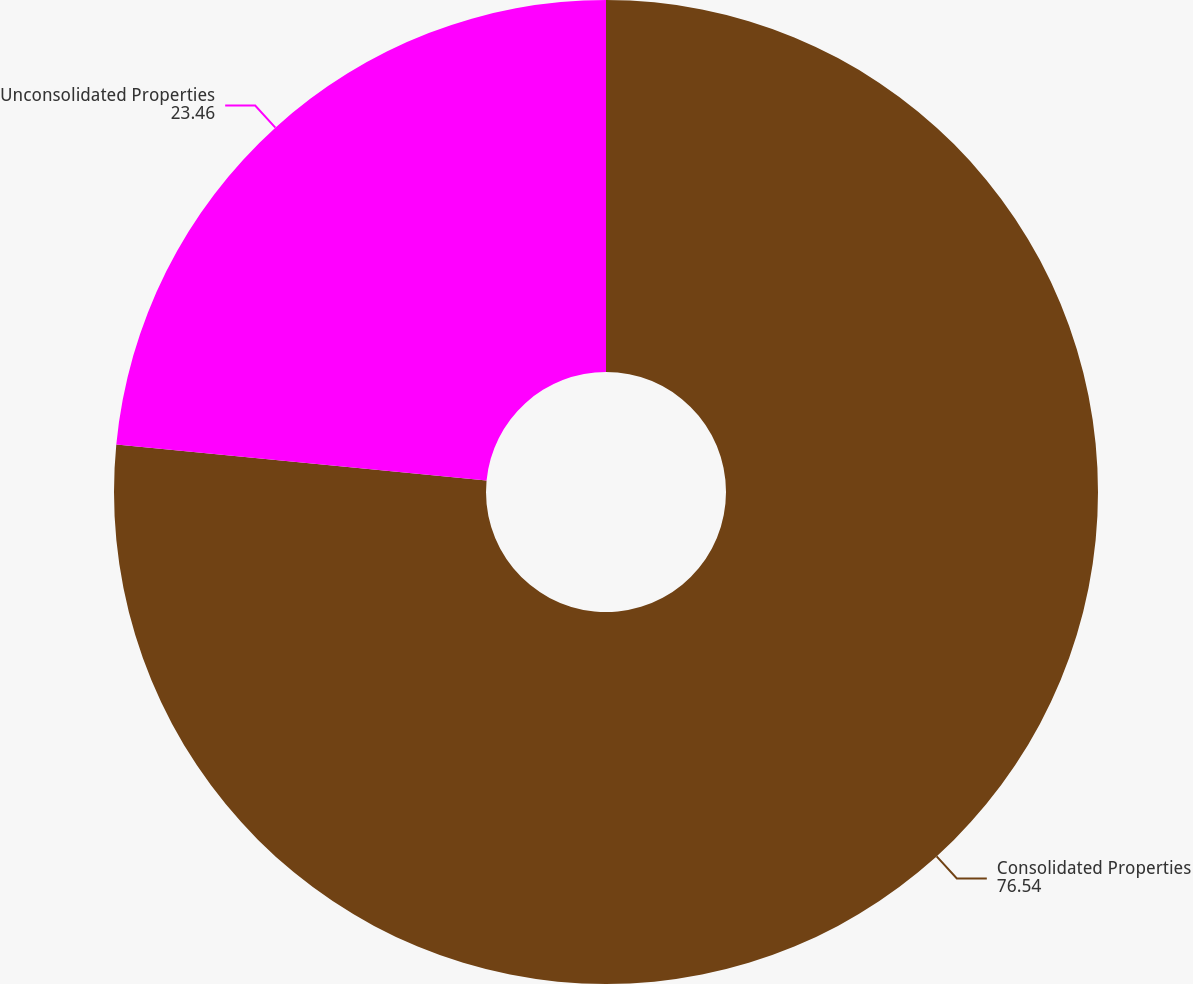Convert chart. <chart><loc_0><loc_0><loc_500><loc_500><pie_chart><fcel>Consolidated Properties<fcel>Unconsolidated Properties<nl><fcel>76.54%<fcel>23.46%<nl></chart> 